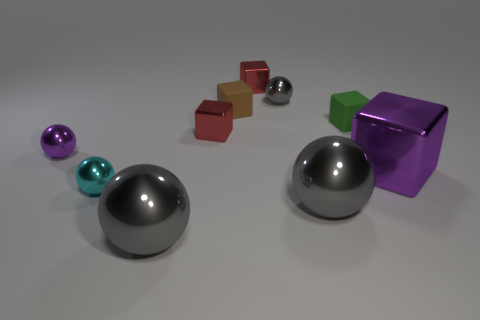There is a cube that is in front of the green object and to the left of the big metallic cube; what material is it made of?
Provide a succinct answer. Metal. How many tiny brown things are the same shape as the green rubber object?
Offer a very short reply. 1. How big is the purple thing on the right side of the object left of the tiny metallic ball that is in front of the big purple cube?
Offer a terse response. Large. Is the number of red objects right of the large purple metallic thing greater than the number of big cyan balls?
Make the answer very short. No. Are there any small shiny spheres?
Your answer should be very brief. Yes. How many green things have the same size as the cyan metal object?
Ensure brevity in your answer.  1. Is the number of small gray shiny objects to the right of the tiny brown object greater than the number of purple metallic cubes that are left of the big purple metal object?
Ensure brevity in your answer.  Yes. There is a purple object that is the same size as the cyan metallic sphere; what is its material?
Provide a succinct answer. Metal. What is the shape of the green object?
Provide a short and direct response. Cube. How many green objects are rubber objects or blocks?
Offer a very short reply. 1. 